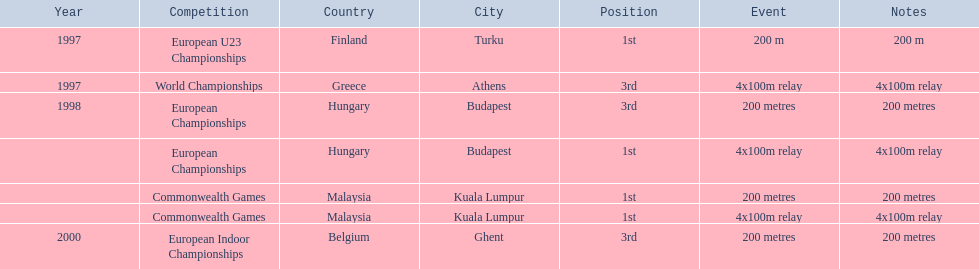How many 4x 100m relays were run? 3. 